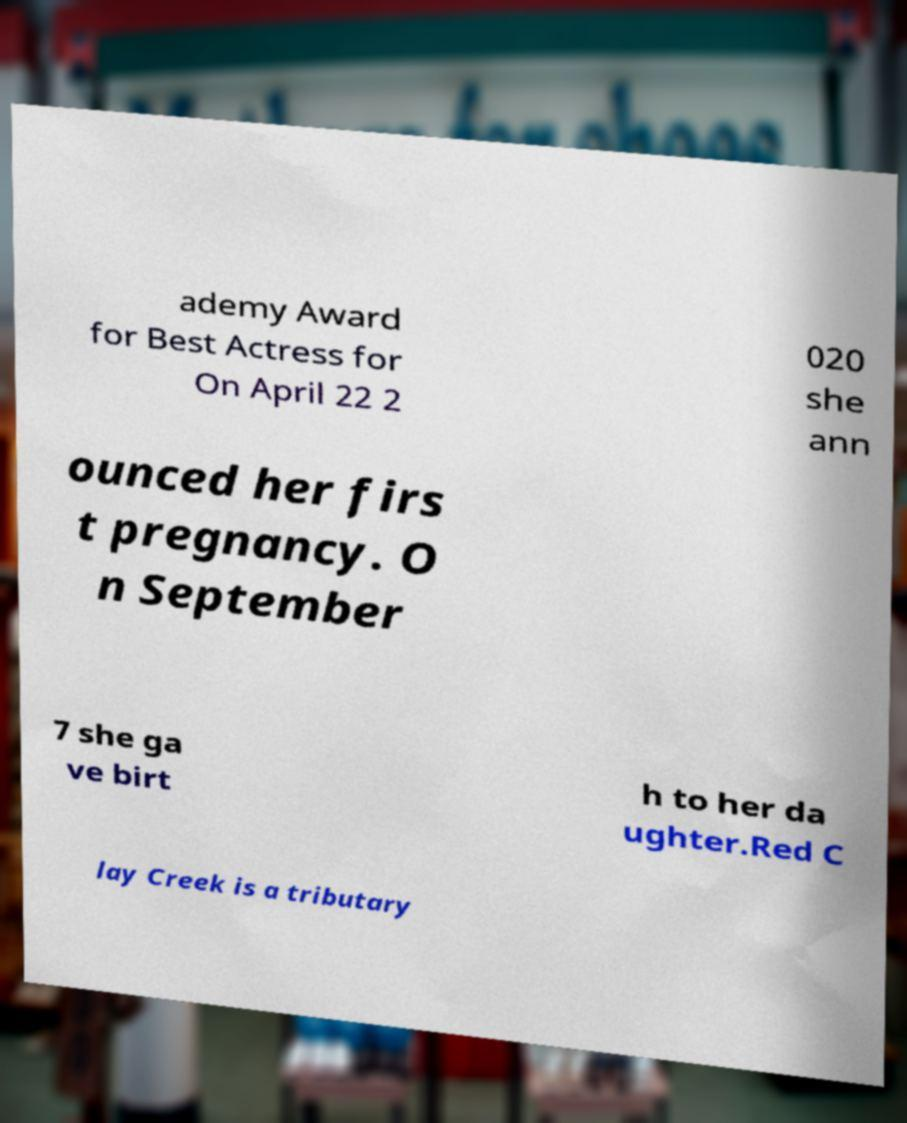What messages or text are displayed in this image? I need them in a readable, typed format. ademy Award for Best Actress for On April 22 2 020 she ann ounced her firs t pregnancy. O n September 7 she ga ve birt h to her da ughter.Red C lay Creek is a tributary 